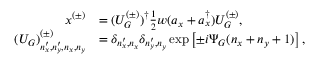<formula> <loc_0><loc_0><loc_500><loc_500>\begin{array} { r l } { x ^ { ( \pm ) } } & { = ( U _ { G } ^ { ( \pm ) } ) ^ { \dag } \frac { 1 } { 2 } w ( a _ { x } + a _ { x } ^ { \dag } ) U _ { G } ^ { ( \pm ) } , } \\ { ( U _ { G } ) _ { n _ { x } ^ { \prime } , n _ { y } ^ { \prime } , n _ { x } , n _ { y } } ^ { ( \pm ) } } & { = \delta _ { n _ { x } ^ { \prime } , n _ { x } } \delta _ { n _ { y } ^ { \prime } , n _ { y } } \exp \left [ \pm i \Psi _ { G } ( n _ { x } + n _ { y } + 1 ) \right ] , } \end{array}</formula> 